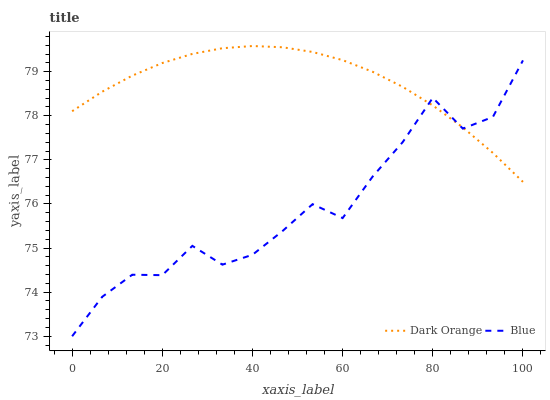Does Blue have the minimum area under the curve?
Answer yes or no. Yes. Does Dark Orange have the maximum area under the curve?
Answer yes or no. Yes. Does Dark Orange have the minimum area under the curve?
Answer yes or no. No. Is Dark Orange the smoothest?
Answer yes or no. Yes. Is Blue the roughest?
Answer yes or no. Yes. Is Dark Orange the roughest?
Answer yes or no. No. Does Blue have the lowest value?
Answer yes or no. Yes. Does Dark Orange have the lowest value?
Answer yes or no. No. Does Dark Orange have the highest value?
Answer yes or no. Yes. Does Dark Orange intersect Blue?
Answer yes or no. Yes. Is Dark Orange less than Blue?
Answer yes or no. No. Is Dark Orange greater than Blue?
Answer yes or no. No. 